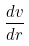Convert formula to latex. <formula><loc_0><loc_0><loc_500><loc_500>\frac { d v } { d r }</formula> 